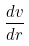Convert formula to latex. <formula><loc_0><loc_0><loc_500><loc_500>\frac { d v } { d r }</formula> 